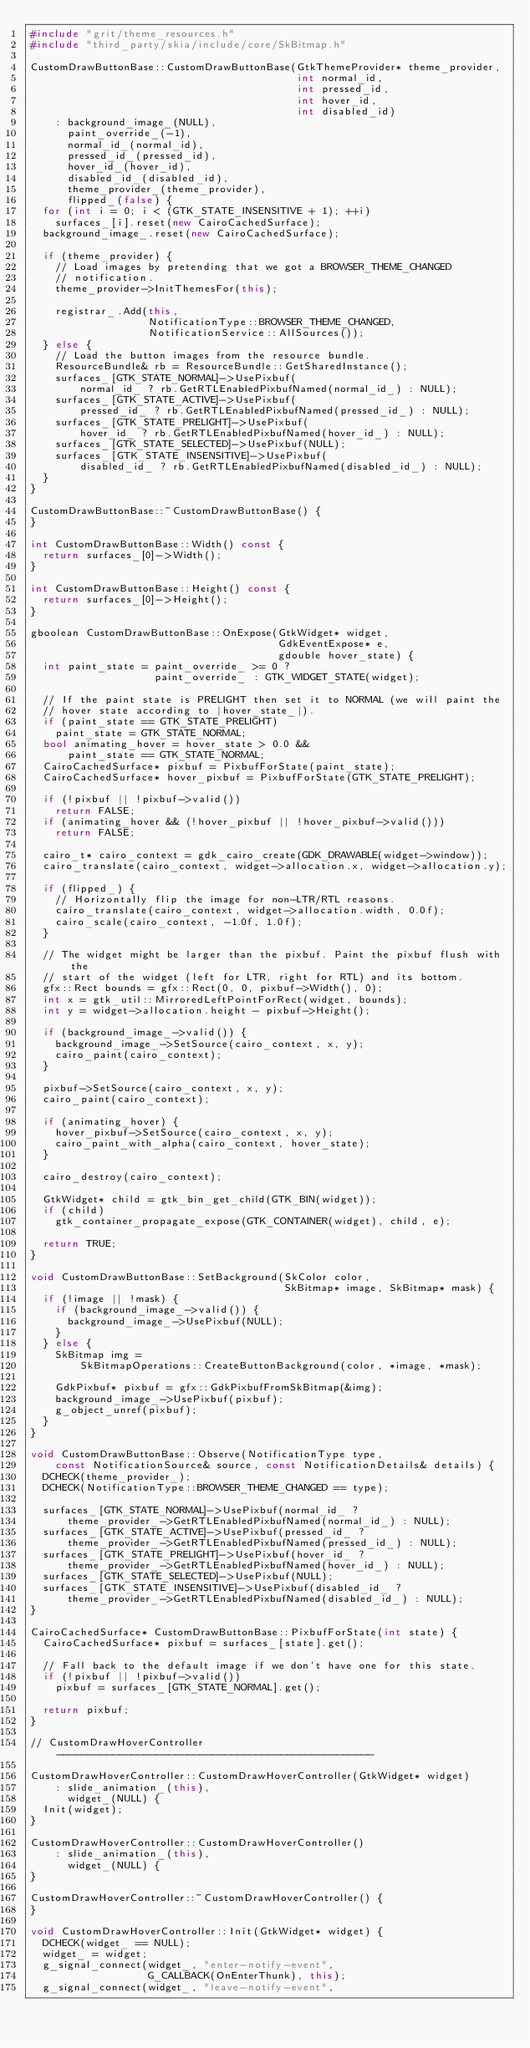Convert code to text. <code><loc_0><loc_0><loc_500><loc_500><_C++_>#include "grit/theme_resources.h"
#include "third_party/skia/include/core/SkBitmap.h"

CustomDrawButtonBase::CustomDrawButtonBase(GtkThemeProvider* theme_provider,
                                           int normal_id,
                                           int pressed_id,
                                           int hover_id,
                                           int disabled_id)
    : background_image_(NULL),
      paint_override_(-1),
      normal_id_(normal_id),
      pressed_id_(pressed_id),
      hover_id_(hover_id),
      disabled_id_(disabled_id),
      theme_provider_(theme_provider),
      flipped_(false) {
  for (int i = 0; i < (GTK_STATE_INSENSITIVE + 1); ++i)
    surfaces_[i].reset(new CairoCachedSurface);
  background_image_.reset(new CairoCachedSurface);

  if (theme_provider) {
    // Load images by pretending that we got a BROWSER_THEME_CHANGED
    // notification.
    theme_provider->InitThemesFor(this);

    registrar_.Add(this,
                   NotificationType::BROWSER_THEME_CHANGED,
                   NotificationService::AllSources());
  } else {
    // Load the button images from the resource bundle.
    ResourceBundle& rb = ResourceBundle::GetSharedInstance();
    surfaces_[GTK_STATE_NORMAL]->UsePixbuf(
        normal_id_ ? rb.GetRTLEnabledPixbufNamed(normal_id_) : NULL);
    surfaces_[GTK_STATE_ACTIVE]->UsePixbuf(
        pressed_id_ ? rb.GetRTLEnabledPixbufNamed(pressed_id_) : NULL);
    surfaces_[GTK_STATE_PRELIGHT]->UsePixbuf(
        hover_id_ ? rb.GetRTLEnabledPixbufNamed(hover_id_) : NULL);
    surfaces_[GTK_STATE_SELECTED]->UsePixbuf(NULL);
    surfaces_[GTK_STATE_INSENSITIVE]->UsePixbuf(
        disabled_id_ ? rb.GetRTLEnabledPixbufNamed(disabled_id_) : NULL);
  }
}

CustomDrawButtonBase::~CustomDrawButtonBase() {
}

int CustomDrawButtonBase::Width() const {
  return surfaces_[0]->Width();
}

int CustomDrawButtonBase::Height() const {
  return surfaces_[0]->Height();
}

gboolean CustomDrawButtonBase::OnExpose(GtkWidget* widget,
                                        GdkEventExpose* e,
                                        gdouble hover_state) {
  int paint_state = paint_override_ >= 0 ?
                    paint_override_ : GTK_WIDGET_STATE(widget);

  // If the paint state is PRELIGHT then set it to NORMAL (we will paint the
  // hover state according to |hover_state_|).
  if (paint_state == GTK_STATE_PRELIGHT)
    paint_state = GTK_STATE_NORMAL;
  bool animating_hover = hover_state > 0.0 &&
      paint_state == GTK_STATE_NORMAL;
  CairoCachedSurface* pixbuf = PixbufForState(paint_state);
  CairoCachedSurface* hover_pixbuf = PixbufForState(GTK_STATE_PRELIGHT);

  if (!pixbuf || !pixbuf->valid())
    return FALSE;
  if (animating_hover && (!hover_pixbuf || !hover_pixbuf->valid()))
    return FALSE;

  cairo_t* cairo_context = gdk_cairo_create(GDK_DRAWABLE(widget->window));
  cairo_translate(cairo_context, widget->allocation.x, widget->allocation.y);

  if (flipped_) {
    // Horizontally flip the image for non-LTR/RTL reasons.
    cairo_translate(cairo_context, widget->allocation.width, 0.0f);
    cairo_scale(cairo_context, -1.0f, 1.0f);
  }

  // The widget might be larger than the pixbuf. Paint the pixbuf flush with the
  // start of the widget (left for LTR, right for RTL) and its bottom.
  gfx::Rect bounds = gfx::Rect(0, 0, pixbuf->Width(), 0);
  int x = gtk_util::MirroredLeftPointForRect(widget, bounds);
  int y = widget->allocation.height - pixbuf->Height();

  if (background_image_->valid()) {
    background_image_->SetSource(cairo_context, x, y);
    cairo_paint(cairo_context);
  }

  pixbuf->SetSource(cairo_context, x, y);
  cairo_paint(cairo_context);

  if (animating_hover) {
    hover_pixbuf->SetSource(cairo_context, x, y);
    cairo_paint_with_alpha(cairo_context, hover_state);
  }

  cairo_destroy(cairo_context);

  GtkWidget* child = gtk_bin_get_child(GTK_BIN(widget));
  if (child)
    gtk_container_propagate_expose(GTK_CONTAINER(widget), child, e);

  return TRUE;
}

void CustomDrawButtonBase::SetBackground(SkColor color,
                                         SkBitmap* image, SkBitmap* mask) {
  if (!image || !mask) {
    if (background_image_->valid()) {
      background_image_->UsePixbuf(NULL);
    }
  } else {
    SkBitmap img =
        SkBitmapOperations::CreateButtonBackground(color, *image, *mask);

    GdkPixbuf* pixbuf = gfx::GdkPixbufFromSkBitmap(&img);
    background_image_->UsePixbuf(pixbuf);
    g_object_unref(pixbuf);
  }
}

void CustomDrawButtonBase::Observe(NotificationType type,
    const NotificationSource& source, const NotificationDetails& details) {
  DCHECK(theme_provider_);
  DCHECK(NotificationType::BROWSER_THEME_CHANGED == type);

  surfaces_[GTK_STATE_NORMAL]->UsePixbuf(normal_id_ ?
      theme_provider_->GetRTLEnabledPixbufNamed(normal_id_) : NULL);
  surfaces_[GTK_STATE_ACTIVE]->UsePixbuf(pressed_id_ ?
      theme_provider_->GetRTLEnabledPixbufNamed(pressed_id_) : NULL);
  surfaces_[GTK_STATE_PRELIGHT]->UsePixbuf(hover_id_ ?
      theme_provider_->GetRTLEnabledPixbufNamed(hover_id_) : NULL);
  surfaces_[GTK_STATE_SELECTED]->UsePixbuf(NULL);
  surfaces_[GTK_STATE_INSENSITIVE]->UsePixbuf(disabled_id_ ?
      theme_provider_->GetRTLEnabledPixbufNamed(disabled_id_) : NULL);
}

CairoCachedSurface* CustomDrawButtonBase::PixbufForState(int state) {
  CairoCachedSurface* pixbuf = surfaces_[state].get();

  // Fall back to the default image if we don't have one for this state.
  if (!pixbuf || !pixbuf->valid())
    pixbuf = surfaces_[GTK_STATE_NORMAL].get();

  return pixbuf;
}

// CustomDrawHoverController ---------------------------------------------------

CustomDrawHoverController::CustomDrawHoverController(GtkWidget* widget)
    : slide_animation_(this),
      widget_(NULL) {
  Init(widget);
}

CustomDrawHoverController::CustomDrawHoverController()
    : slide_animation_(this),
      widget_(NULL) {
}

CustomDrawHoverController::~CustomDrawHoverController() {
}

void CustomDrawHoverController::Init(GtkWidget* widget) {
  DCHECK(widget_ == NULL);
  widget_ = widget;
  g_signal_connect(widget_, "enter-notify-event",
                   G_CALLBACK(OnEnterThunk), this);
  g_signal_connect(widget_, "leave-notify-event",</code> 